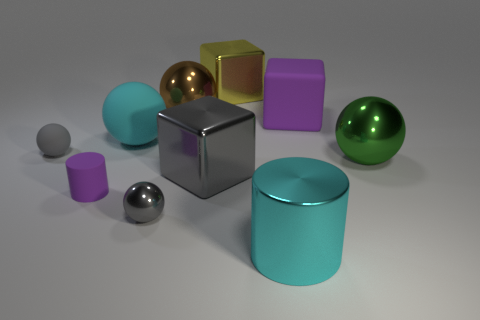What number of other things are the same color as the small cylinder?
Provide a short and direct response. 1. How many brown things are big cubes or big rubber objects?
Keep it short and to the point. 0. There is a shiny thing behind the brown object; does it have the same size as the matte sphere that is in front of the big cyan matte object?
Make the answer very short. No. How many objects are big brown shiny spheres or gray shiny spheres?
Provide a succinct answer. 2. Are there any other shiny things of the same shape as the large gray thing?
Your answer should be very brief. Yes. Are there fewer shiny objects than cyan metal things?
Your response must be concise. No. Do the large gray object and the tiny gray matte thing have the same shape?
Make the answer very short. No. How many objects are big green spheres or metal things on the right side of the big gray object?
Keep it short and to the point. 3. What number of small purple cylinders are there?
Make the answer very short. 1. Is there a red matte cube that has the same size as the purple matte cube?
Provide a short and direct response. No. 